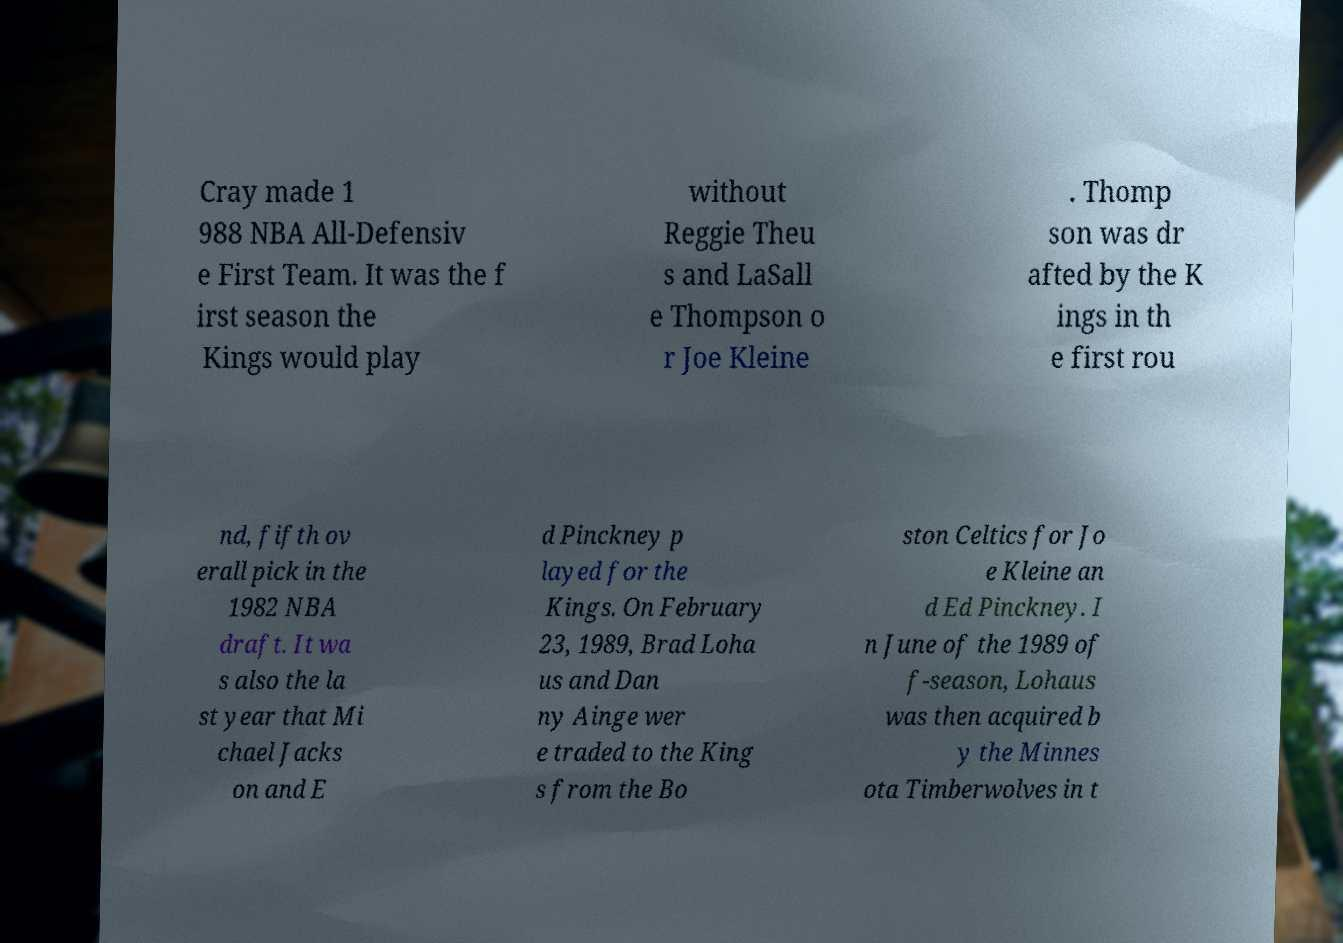Please read and relay the text visible in this image. What does it say? Cray made 1 988 NBA All-Defensiv e First Team. It was the f irst season the Kings would play without Reggie Theu s and LaSall e Thompson o r Joe Kleine . Thomp son was dr afted by the K ings in th e first rou nd, fifth ov erall pick in the 1982 NBA draft. It wa s also the la st year that Mi chael Jacks on and E d Pinckney p layed for the Kings. On February 23, 1989, Brad Loha us and Dan ny Ainge wer e traded to the King s from the Bo ston Celtics for Jo e Kleine an d Ed Pinckney. I n June of the 1989 of f-season, Lohaus was then acquired b y the Minnes ota Timberwolves in t 